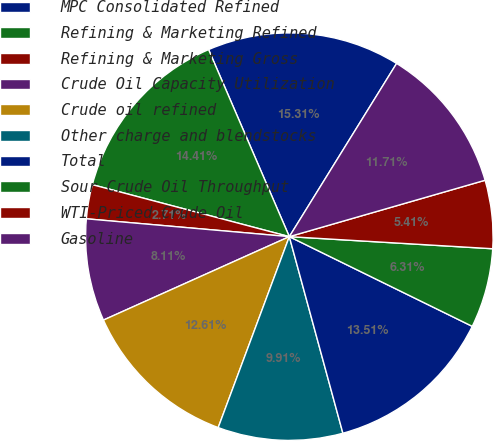<chart> <loc_0><loc_0><loc_500><loc_500><pie_chart><fcel>MPC Consolidated Refined<fcel>Refining & Marketing Refined<fcel>Refining & Marketing Gross<fcel>Crude Oil Capacity Utilization<fcel>Crude oil refined<fcel>Other charge and blendstocks<fcel>Total<fcel>Sour Crude Oil Throughput<fcel>WTI-Priced Crude Oil<fcel>Gasoline<nl><fcel>15.31%<fcel>14.41%<fcel>2.71%<fcel>8.11%<fcel>12.61%<fcel>9.91%<fcel>13.51%<fcel>6.31%<fcel>5.41%<fcel>11.71%<nl></chart> 